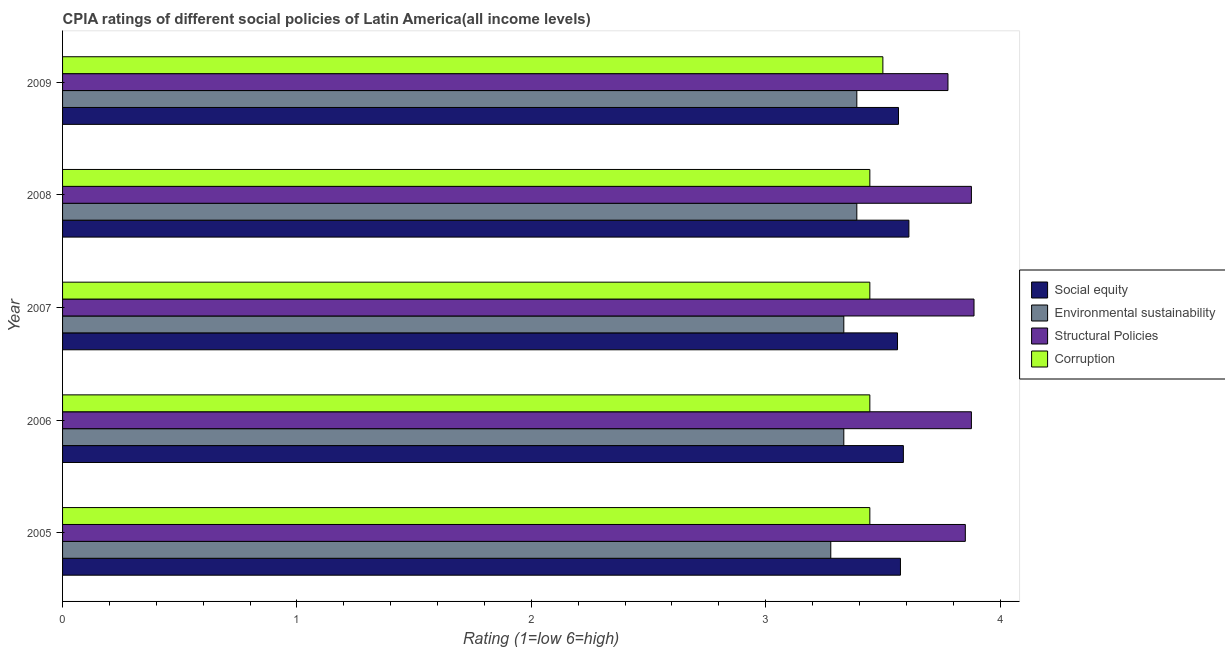Are the number of bars per tick equal to the number of legend labels?
Give a very brief answer. Yes. Are the number of bars on each tick of the Y-axis equal?
Your answer should be very brief. Yes. How many bars are there on the 4th tick from the top?
Offer a very short reply. 4. What is the label of the 2nd group of bars from the top?
Provide a short and direct response. 2008. What is the cpia rating of environmental sustainability in 2008?
Your answer should be very brief. 3.39. Across all years, what is the maximum cpia rating of structural policies?
Make the answer very short. 3.89. Across all years, what is the minimum cpia rating of environmental sustainability?
Give a very brief answer. 3.28. In which year was the cpia rating of structural policies maximum?
Give a very brief answer. 2007. In which year was the cpia rating of social equity minimum?
Offer a very short reply. 2007. What is the total cpia rating of structural policies in the graph?
Your answer should be compact. 19.27. What is the difference between the cpia rating of social equity in 2007 and that in 2008?
Provide a short and direct response. -0.05. What is the difference between the cpia rating of structural policies in 2009 and the cpia rating of corruption in 2005?
Provide a short and direct response. 0.33. What is the average cpia rating of structural policies per year?
Your answer should be very brief. 3.85. In the year 2009, what is the difference between the cpia rating of social equity and cpia rating of corruption?
Your response must be concise. 0.07. In how many years, is the cpia rating of environmental sustainability greater than 2.4 ?
Provide a short and direct response. 5. Is the cpia rating of social equity in 2007 less than that in 2008?
Give a very brief answer. Yes. Is the difference between the cpia rating of environmental sustainability in 2008 and 2009 greater than the difference between the cpia rating of social equity in 2008 and 2009?
Keep it short and to the point. No. What is the difference between the highest and the lowest cpia rating of structural policies?
Make the answer very short. 0.11. What does the 4th bar from the top in 2009 represents?
Offer a very short reply. Social equity. What does the 2nd bar from the bottom in 2005 represents?
Give a very brief answer. Environmental sustainability. Is it the case that in every year, the sum of the cpia rating of social equity and cpia rating of environmental sustainability is greater than the cpia rating of structural policies?
Offer a very short reply. Yes. How many bars are there?
Make the answer very short. 20. Are the values on the major ticks of X-axis written in scientific E-notation?
Provide a short and direct response. No. Does the graph contain grids?
Give a very brief answer. No. How many legend labels are there?
Your answer should be compact. 4. What is the title of the graph?
Offer a terse response. CPIA ratings of different social policies of Latin America(all income levels). What is the Rating (1=low 6=high) in Social equity in 2005?
Keep it short and to the point. 3.58. What is the Rating (1=low 6=high) in Environmental sustainability in 2005?
Offer a very short reply. 3.28. What is the Rating (1=low 6=high) of Structural Policies in 2005?
Keep it short and to the point. 3.85. What is the Rating (1=low 6=high) of Corruption in 2005?
Offer a very short reply. 3.44. What is the Rating (1=low 6=high) in Social equity in 2006?
Offer a very short reply. 3.59. What is the Rating (1=low 6=high) of Environmental sustainability in 2006?
Offer a terse response. 3.33. What is the Rating (1=low 6=high) of Structural Policies in 2006?
Provide a succinct answer. 3.88. What is the Rating (1=low 6=high) in Corruption in 2006?
Ensure brevity in your answer.  3.44. What is the Rating (1=low 6=high) of Social equity in 2007?
Ensure brevity in your answer.  3.56. What is the Rating (1=low 6=high) of Environmental sustainability in 2007?
Give a very brief answer. 3.33. What is the Rating (1=low 6=high) in Structural Policies in 2007?
Your answer should be compact. 3.89. What is the Rating (1=low 6=high) of Corruption in 2007?
Offer a terse response. 3.44. What is the Rating (1=low 6=high) of Social equity in 2008?
Keep it short and to the point. 3.61. What is the Rating (1=low 6=high) of Environmental sustainability in 2008?
Your answer should be compact. 3.39. What is the Rating (1=low 6=high) in Structural Policies in 2008?
Provide a short and direct response. 3.88. What is the Rating (1=low 6=high) of Corruption in 2008?
Your answer should be very brief. 3.44. What is the Rating (1=low 6=high) of Social equity in 2009?
Your response must be concise. 3.57. What is the Rating (1=low 6=high) of Environmental sustainability in 2009?
Give a very brief answer. 3.39. What is the Rating (1=low 6=high) in Structural Policies in 2009?
Provide a succinct answer. 3.78. Across all years, what is the maximum Rating (1=low 6=high) in Social equity?
Provide a short and direct response. 3.61. Across all years, what is the maximum Rating (1=low 6=high) of Environmental sustainability?
Your answer should be compact. 3.39. Across all years, what is the maximum Rating (1=low 6=high) of Structural Policies?
Make the answer very short. 3.89. Across all years, what is the minimum Rating (1=low 6=high) in Social equity?
Your answer should be compact. 3.56. Across all years, what is the minimum Rating (1=low 6=high) of Environmental sustainability?
Provide a short and direct response. 3.28. Across all years, what is the minimum Rating (1=low 6=high) in Structural Policies?
Make the answer very short. 3.78. Across all years, what is the minimum Rating (1=low 6=high) in Corruption?
Give a very brief answer. 3.44. What is the total Rating (1=low 6=high) of Social equity in the graph?
Your answer should be very brief. 17.9. What is the total Rating (1=low 6=high) in Environmental sustainability in the graph?
Give a very brief answer. 16.72. What is the total Rating (1=low 6=high) in Structural Policies in the graph?
Give a very brief answer. 19.27. What is the total Rating (1=low 6=high) of Corruption in the graph?
Ensure brevity in your answer.  17.28. What is the difference between the Rating (1=low 6=high) in Social equity in 2005 and that in 2006?
Provide a short and direct response. -0.01. What is the difference between the Rating (1=low 6=high) in Environmental sustainability in 2005 and that in 2006?
Offer a very short reply. -0.06. What is the difference between the Rating (1=low 6=high) of Structural Policies in 2005 and that in 2006?
Your answer should be compact. -0.03. What is the difference between the Rating (1=low 6=high) in Corruption in 2005 and that in 2006?
Provide a succinct answer. 0. What is the difference between the Rating (1=low 6=high) of Social equity in 2005 and that in 2007?
Your response must be concise. 0.01. What is the difference between the Rating (1=low 6=high) in Environmental sustainability in 2005 and that in 2007?
Make the answer very short. -0.06. What is the difference between the Rating (1=low 6=high) in Structural Policies in 2005 and that in 2007?
Your answer should be very brief. -0.04. What is the difference between the Rating (1=low 6=high) in Social equity in 2005 and that in 2008?
Ensure brevity in your answer.  -0.04. What is the difference between the Rating (1=low 6=high) in Environmental sustainability in 2005 and that in 2008?
Your answer should be compact. -0.11. What is the difference between the Rating (1=low 6=high) of Structural Policies in 2005 and that in 2008?
Your answer should be very brief. -0.03. What is the difference between the Rating (1=low 6=high) of Corruption in 2005 and that in 2008?
Provide a succinct answer. 0. What is the difference between the Rating (1=low 6=high) of Social equity in 2005 and that in 2009?
Your response must be concise. 0.01. What is the difference between the Rating (1=low 6=high) in Environmental sustainability in 2005 and that in 2009?
Provide a short and direct response. -0.11. What is the difference between the Rating (1=low 6=high) in Structural Policies in 2005 and that in 2009?
Your answer should be very brief. 0.07. What is the difference between the Rating (1=low 6=high) in Corruption in 2005 and that in 2009?
Offer a very short reply. -0.06. What is the difference between the Rating (1=low 6=high) in Social equity in 2006 and that in 2007?
Your answer should be very brief. 0.03. What is the difference between the Rating (1=low 6=high) of Environmental sustainability in 2006 and that in 2007?
Your answer should be compact. 0. What is the difference between the Rating (1=low 6=high) in Structural Policies in 2006 and that in 2007?
Give a very brief answer. -0.01. What is the difference between the Rating (1=low 6=high) in Corruption in 2006 and that in 2007?
Offer a terse response. 0. What is the difference between the Rating (1=low 6=high) in Social equity in 2006 and that in 2008?
Your response must be concise. -0.02. What is the difference between the Rating (1=low 6=high) in Environmental sustainability in 2006 and that in 2008?
Your response must be concise. -0.06. What is the difference between the Rating (1=low 6=high) of Social equity in 2006 and that in 2009?
Offer a terse response. 0.02. What is the difference between the Rating (1=low 6=high) in Environmental sustainability in 2006 and that in 2009?
Keep it short and to the point. -0.06. What is the difference between the Rating (1=low 6=high) of Structural Policies in 2006 and that in 2009?
Your response must be concise. 0.1. What is the difference between the Rating (1=low 6=high) of Corruption in 2006 and that in 2009?
Make the answer very short. -0.06. What is the difference between the Rating (1=low 6=high) of Social equity in 2007 and that in 2008?
Ensure brevity in your answer.  -0.05. What is the difference between the Rating (1=low 6=high) in Environmental sustainability in 2007 and that in 2008?
Make the answer very short. -0.06. What is the difference between the Rating (1=low 6=high) in Structural Policies in 2007 and that in 2008?
Your answer should be very brief. 0.01. What is the difference between the Rating (1=low 6=high) in Corruption in 2007 and that in 2008?
Give a very brief answer. 0. What is the difference between the Rating (1=low 6=high) of Social equity in 2007 and that in 2009?
Provide a succinct answer. -0. What is the difference between the Rating (1=low 6=high) in Environmental sustainability in 2007 and that in 2009?
Your response must be concise. -0.06. What is the difference between the Rating (1=low 6=high) in Corruption in 2007 and that in 2009?
Offer a terse response. -0.06. What is the difference between the Rating (1=low 6=high) in Social equity in 2008 and that in 2009?
Ensure brevity in your answer.  0.04. What is the difference between the Rating (1=low 6=high) in Environmental sustainability in 2008 and that in 2009?
Offer a very short reply. 0. What is the difference between the Rating (1=low 6=high) of Corruption in 2008 and that in 2009?
Provide a short and direct response. -0.06. What is the difference between the Rating (1=low 6=high) of Social equity in 2005 and the Rating (1=low 6=high) of Environmental sustainability in 2006?
Offer a terse response. 0.24. What is the difference between the Rating (1=low 6=high) in Social equity in 2005 and the Rating (1=low 6=high) in Structural Policies in 2006?
Provide a short and direct response. -0.3. What is the difference between the Rating (1=low 6=high) of Social equity in 2005 and the Rating (1=low 6=high) of Corruption in 2006?
Make the answer very short. 0.13. What is the difference between the Rating (1=low 6=high) in Environmental sustainability in 2005 and the Rating (1=low 6=high) in Corruption in 2006?
Provide a succinct answer. -0.17. What is the difference between the Rating (1=low 6=high) of Structural Policies in 2005 and the Rating (1=low 6=high) of Corruption in 2006?
Offer a very short reply. 0.41. What is the difference between the Rating (1=low 6=high) of Social equity in 2005 and the Rating (1=low 6=high) of Environmental sustainability in 2007?
Make the answer very short. 0.24. What is the difference between the Rating (1=low 6=high) in Social equity in 2005 and the Rating (1=low 6=high) in Structural Policies in 2007?
Your answer should be very brief. -0.31. What is the difference between the Rating (1=low 6=high) of Social equity in 2005 and the Rating (1=low 6=high) of Corruption in 2007?
Your response must be concise. 0.13. What is the difference between the Rating (1=low 6=high) in Environmental sustainability in 2005 and the Rating (1=low 6=high) in Structural Policies in 2007?
Your response must be concise. -0.61. What is the difference between the Rating (1=low 6=high) in Environmental sustainability in 2005 and the Rating (1=low 6=high) in Corruption in 2007?
Give a very brief answer. -0.17. What is the difference between the Rating (1=low 6=high) of Structural Policies in 2005 and the Rating (1=low 6=high) of Corruption in 2007?
Your answer should be compact. 0.41. What is the difference between the Rating (1=low 6=high) in Social equity in 2005 and the Rating (1=low 6=high) in Environmental sustainability in 2008?
Give a very brief answer. 0.19. What is the difference between the Rating (1=low 6=high) of Social equity in 2005 and the Rating (1=low 6=high) of Structural Policies in 2008?
Make the answer very short. -0.3. What is the difference between the Rating (1=low 6=high) in Social equity in 2005 and the Rating (1=low 6=high) in Corruption in 2008?
Make the answer very short. 0.13. What is the difference between the Rating (1=low 6=high) in Environmental sustainability in 2005 and the Rating (1=low 6=high) in Corruption in 2008?
Offer a terse response. -0.17. What is the difference between the Rating (1=low 6=high) in Structural Policies in 2005 and the Rating (1=low 6=high) in Corruption in 2008?
Offer a terse response. 0.41. What is the difference between the Rating (1=low 6=high) in Social equity in 2005 and the Rating (1=low 6=high) in Environmental sustainability in 2009?
Ensure brevity in your answer.  0.19. What is the difference between the Rating (1=low 6=high) of Social equity in 2005 and the Rating (1=low 6=high) of Structural Policies in 2009?
Offer a very short reply. -0.2. What is the difference between the Rating (1=low 6=high) of Social equity in 2005 and the Rating (1=low 6=high) of Corruption in 2009?
Ensure brevity in your answer.  0.07. What is the difference between the Rating (1=low 6=high) of Environmental sustainability in 2005 and the Rating (1=low 6=high) of Structural Policies in 2009?
Make the answer very short. -0.5. What is the difference between the Rating (1=low 6=high) of Environmental sustainability in 2005 and the Rating (1=low 6=high) of Corruption in 2009?
Provide a succinct answer. -0.22. What is the difference between the Rating (1=low 6=high) of Structural Policies in 2005 and the Rating (1=low 6=high) of Corruption in 2009?
Offer a very short reply. 0.35. What is the difference between the Rating (1=low 6=high) of Social equity in 2006 and the Rating (1=low 6=high) of Environmental sustainability in 2007?
Provide a short and direct response. 0.25. What is the difference between the Rating (1=low 6=high) in Social equity in 2006 and the Rating (1=low 6=high) in Structural Policies in 2007?
Keep it short and to the point. -0.3. What is the difference between the Rating (1=low 6=high) in Social equity in 2006 and the Rating (1=low 6=high) in Corruption in 2007?
Your answer should be very brief. 0.14. What is the difference between the Rating (1=low 6=high) in Environmental sustainability in 2006 and the Rating (1=low 6=high) in Structural Policies in 2007?
Your answer should be very brief. -0.56. What is the difference between the Rating (1=low 6=high) in Environmental sustainability in 2006 and the Rating (1=low 6=high) in Corruption in 2007?
Provide a short and direct response. -0.11. What is the difference between the Rating (1=low 6=high) of Structural Policies in 2006 and the Rating (1=low 6=high) of Corruption in 2007?
Offer a terse response. 0.43. What is the difference between the Rating (1=low 6=high) of Social equity in 2006 and the Rating (1=low 6=high) of Environmental sustainability in 2008?
Your answer should be compact. 0.2. What is the difference between the Rating (1=low 6=high) in Social equity in 2006 and the Rating (1=low 6=high) in Structural Policies in 2008?
Provide a short and direct response. -0.29. What is the difference between the Rating (1=low 6=high) in Social equity in 2006 and the Rating (1=low 6=high) in Corruption in 2008?
Provide a short and direct response. 0.14. What is the difference between the Rating (1=low 6=high) in Environmental sustainability in 2006 and the Rating (1=low 6=high) in Structural Policies in 2008?
Offer a very short reply. -0.54. What is the difference between the Rating (1=low 6=high) of Environmental sustainability in 2006 and the Rating (1=low 6=high) of Corruption in 2008?
Offer a terse response. -0.11. What is the difference between the Rating (1=low 6=high) of Structural Policies in 2006 and the Rating (1=low 6=high) of Corruption in 2008?
Offer a terse response. 0.43. What is the difference between the Rating (1=low 6=high) in Social equity in 2006 and the Rating (1=low 6=high) in Environmental sustainability in 2009?
Provide a short and direct response. 0.2. What is the difference between the Rating (1=low 6=high) of Social equity in 2006 and the Rating (1=low 6=high) of Structural Policies in 2009?
Make the answer very short. -0.19. What is the difference between the Rating (1=low 6=high) in Social equity in 2006 and the Rating (1=low 6=high) in Corruption in 2009?
Provide a short and direct response. 0.09. What is the difference between the Rating (1=low 6=high) of Environmental sustainability in 2006 and the Rating (1=low 6=high) of Structural Policies in 2009?
Make the answer very short. -0.44. What is the difference between the Rating (1=low 6=high) of Structural Policies in 2006 and the Rating (1=low 6=high) of Corruption in 2009?
Your answer should be very brief. 0.38. What is the difference between the Rating (1=low 6=high) in Social equity in 2007 and the Rating (1=low 6=high) in Environmental sustainability in 2008?
Your answer should be very brief. 0.17. What is the difference between the Rating (1=low 6=high) of Social equity in 2007 and the Rating (1=low 6=high) of Structural Policies in 2008?
Give a very brief answer. -0.32. What is the difference between the Rating (1=low 6=high) of Social equity in 2007 and the Rating (1=low 6=high) of Corruption in 2008?
Provide a short and direct response. 0.12. What is the difference between the Rating (1=low 6=high) in Environmental sustainability in 2007 and the Rating (1=low 6=high) in Structural Policies in 2008?
Your response must be concise. -0.54. What is the difference between the Rating (1=low 6=high) in Environmental sustainability in 2007 and the Rating (1=low 6=high) in Corruption in 2008?
Give a very brief answer. -0.11. What is the difference between the Rating (1=low 6=high) in Structural Policies in 2007 and the Rating (1=low 6=high) in Corruption in 2008?
Your answer should be very brief. 0.44. What is the difference between the Rating (1=low 6=high) of Social equity in 2007 and the Rating (1=low 6=high) of Environmental sustainability in 2009?
Your answer should be compact. 0.17. What is the difference between the Rating (1=low 6=high) in Social equity in 2007 and the Rating (1=low 6=high) in Structural Policies in 2009?
Make the answer very short. -0.22. What is the difference between the Rating (1=low 6=high) in Social equity in 2007 and the Rating (1=low 6=high) in Corruption in 2009?
Provide a succinct answer. 0.06. What is the difference between the Rating (1=low 6=high) of Environmental sustainability in 2007 and the Rating (1=low 6=high) of Structural Policies in 2009?
Provide a short and direct response. -0.44. What is the difference between the Rating (1=low 6=high) of Environmental sustainability in 2007 and the Rating (1=low 6=high) of Corruption in 2009?
Make the answer very short. -0.17. What is the difference between the Rating (1=low 6=high) of Structural Policies in 2007 and the Rating (1=low 6=high) of Corruption in 2009?
Make the answer very short. 0.39. What is the difference between the Rating (1=low 6=high) in Social equity in 2008 and the Rating (1=low 6=high) in Environmental sustainability in 2009?
Your answer should be very brief. 0.22. What is the difference between the Rating (1=low 6=high) in Environmental sustainability in 2008 and the Rating (1=low 6=high) in Structural Policies in 2009?
Your answer should be very brief. -0.39. What is the difference between the Rating (1=low 6=high) of Environmental sustainability in 2008 and the Rating (1=low 6=high) of Corruption in 2009?
Keep it short and to the point. -0.11. What is the difference between the Rating (1=low 6=high) in Structural Policies in 2008 and the Rating (1=low 6=high) in Corruption in 2009?
Provide a short and direct response. 0.38. What is the average Rating (1=low 6=high) in Social equity per year?
Your answer should be very brief. 3.58. What is the average Rating (1=low 6=high) in Environmental sustainability per year?
Your answer should be compact. 3.34. What is the average Rating (1=low 6=high) of Structural Policies per year?
Provide a succinct answer. 3.85. What is the average Rating (1=low 6=high) of Corruption per year?
Offer a very short reply. 3.46. In the year 2005, what is the difference between the Rating (1=low 6=high) of Social equity and Rating (1=low 6=high) of Environmental sustainability?
Your response must be concise. 0.3. In the year 2005, what is the difference between the Rating (1=low 6=high) in Social equity and Rating (1=low 6=high) in Structural Policies?
Your response must be concise. -0.28. In the year 2005, what is the difference between the Rating (1=low 6=high) in Social equity and Rating (1=low 6=high) in Corruption?
Your answer should be compact. 0.13. In the year 2005, what is the difference between the Rating (1=low 6=high) of Environmental sustainability and Rating (1=low 6=high) of Structural Policies?
Your response must be concise. -0.57. In the year 2005, what is the difference between the Rating (1=low 6=high) of Environmental sustainability and Rating (1=low 6=high) of Corruption?
Make the answer very short. -0.17. In the year 2005, what is the difference between the Rating (1=low 6=high) of Structural Policies and Rating (1=low 6=high) of Corruption?
Make the answer very short. 0.41. In the year 2006, what is the difference between the Rating (1=low 6=high) in Social equity and Rating (1=low 6=high) in Environmental sustainability?
Your response must be concise. 0.25. In the year 2006, what is the difference between the Rating (1=low 6=high) of Social equity and Rating (1=low 6=high) of Structural Policies?
Offer a very short reply. -0.29. In the year 2006, what is the difference between the Rating (1=low 6=high) in Social equity and Rating (1=low 6=high) in Corruption?
Provide a succinct answer. 0.14. In the year 2006, what is the difference between the Rating (1=low 6=high) in Environmental sustainability and Rating (1=low 6=high) in Structural Policies?
Your response must be concise. -0.54. In the year 2006, what is the difference between the Rating (1=low 6=high) in Environmental sustainability and Rating (1=low 6=high) in Corruption?
Your answer should be very brief. -0.11. In the year 2006, what is the difference between the Rating (1=low 6=high) of Structural Policies and Rating (1=low 6=high) of Corruption?
Your answer should be compact. 0.43. In the year 2007, what is the difference between the Rating (1=low 6=high) in Social equity and Rating (1=low 6=high) in Environmental sustainability?
Offer a terse response. 0.23. In the year 2007, what is the difference between the Rating (1=low 6=high) in Social equity and Rating (1=low 6=high) in Structural Policies?
Keep it short and to the point. -0.33. In the year 2007, what is the difference between the Rating (1=low 6=high) in Social equity and Rating (1=low 6=high) in Corruption?
Offer a very short reply. 0.12. In the year 2007, what is the difference between the Rating (1=low 6=high) in Environmental sustainability and Rating (1=low 6=high) in Structural Policies?
Make the answer very short. -0.56. In the year 2007, what is the difference between the Rating (1=low 6=high) in Environmental sustainability and Rating (1=low 6=high) in Corruption?
Ensure brevity in your answer.  -0.11. In the year 2007, what is the difference between the Rating (1=low 6=high) in Structural Policies and Rating (1=low 6=high) in Corruption?
Provide a short and direct response. 0.44. In the year 2008, what is the difference between the Rating (1=low 6=high) of Social equity and Rating (1=low 6=high) of Environmental sustainability?
Keep it short and to the point. 0.22. In the year 2008, what is the difference between the Rating (1=low 6=high) of Social equity and Rating (1=low 6=high) of Structural Policies?
Your answer should be very brief. -0.27. In the year 2008, what is the difference between the Rating (1=low 6=high) of Social equity and Rating (1=low 6=high) of Corruption?
Ensure brevity in your answer.  0.17. In the year 2008, what is the difference between the Rating (1=low 6=high) in Environmental sustainability and Rating (1=low 6=high) in Structural Policies?
Ensure brevity in your answer.  -0.49. In the year 2008, what is the difference between the Rating (1=low 6=high) in Environmental sustainability and Rating (1=low 6=high) in Corruption?
Your response must be concise. -0.06. In the year 2008, what is the difference between the Rating (1=low 6=high) of Structural Policies and Rating (1=low 6=high) of Corruption?
Give a very brief answer. 0.43. In the year 2009, what is the difference between the Rating (1=low 6=high) of Social equity and Rating (1=low 6=high) of Environmental sustainability?
Offer a very short reply. 0.18. In the year 2009, what is the difference between the Rating (1=low 6=high) in Social equity and Rating (1=low 6=high) in Structural Policies?
Your answer should be very brief. -0.21. In the year 2009, what is the difference between the Rating (1=low 6=high) of Social equity and Rating (1=low 6=high) of Corruption?
Provide a succinct answer. 0.07. In the year 2009, what is the difference between the Rating (1=low 6=high) of Environmental sustainability and Rating (1=low 6=high) of Structural Policies?
Offer a terse response. -0.39. In the year 2009, what is the difference between the Rating (1=low 6=high) of Environmental sustainability and Rating (1=low 6=high) of Corruption?
Your answer should be very brief. -0.11. In the year 2009, what is the difference between the Rating (1=low 6=high) of Structural Policies and Rating (1=low 6=high) of Corruption?
Offer a very short reply. 0.28. What is the ratio of the Rating (1=low 6=high) of Environmental sustainability in 2005 to that in 2006?
Ensure brevity in your answer.  0.98. What is the ratio of the Rating (1=low 6=high) of Corruption in 2005 to that in 2006?
Your answer should be very brief. 1. What is the ratio of the Rating (1=low 6=high) in Social equity in 2005 to that in 2007?
Offer a terse response. 1. What is the ratio of the Rating (1=low 6=high) of Environmental sustainability in 2005 to that in 2007?
Your response must be concise. 0.98. What is the ratio of the Rating (1=low 6=high) of Structural Policies in 2005 to that in 2007?
Ensure brevity in your answer.  0.99. What is the ratio of the Rating (1=low 6=high) of Environmental sustainability in 2005 to that in 2008?
Provide a succinct answer. 0.97. What is the ratio of the Rating (1=low 6=high) in Structural Policies in 2005 to that in 2008?
Your answer should be very brief. 0.99. What is the ratio of the Rating (1=low 6=high) in Social equity in 2005 to that in 2009?
Make the answer very short. 1. What is the ratio of the Rating (1=low 6=high) in Environmental sustainability in 2005 to that in 2009?
Make the answer very short. 0.97. What is the ratio of the Rating (1=low 6=high) of Structural Policies in 2005 to that in 2009?
Make the answer very short. 1.02. What is the ratio of the Rating (1=low 6=high) of Corruption in 2005 to that in 2009?
Provide a succinct answer. 0.98. What is the ratio of the Rating (1=low 6=high) of Social equity in 2006 to that in 2007?
Provide a succinct answer. 1.01. What is the ratio of the Rating (1=low 6=high) of Corruption in 2006 to that in 2007?
Provide a short and direct response. 1. What is the ratio of the Rating (1=low 6=high) of Environmental sustainability in 2006 to that in 2008?
Give a very brief answer. 0.98. What is the ratio of the Rating (1=low 6=high) in Structural Policies in 2006 to that in 2008?
Your answer should be very brief. 1. What is the ratio of the Rating (1=low 6=high) of Social equity in 2006 to that in 2009?
Make the answer very short. 1.01. What is the ratio of the Rating (1=low 6=high) in Environmental sustainability in 2006 to that in 2009?
Keep it short and to the point. 0.98. What is the ratio of the Rating (1=low 6=high) of Structural Policies in 2006 to that in 2009?
Offer a terse response. 1.03. What is the ratio of the Rating (1=low 6=high) of Corruption in 2006 to that in 2009?
Your response must be concise. 0.98. What is the ratio of the Rating (1=low 6=high) in Social equity in 2007 to that in 2008?
Provide a succinct answer. 0.99. What is the ratio of the Rating (1=low 6=high) in Environmental sustainability in 2007 to that in 2008?
Provide a succinct answer. 0.98. What is the ratio of the Rating (1=low 6=high) in Social equity in 2007 to that in 2009?
Your response must be concise. 1. What is the ratio of the Rating (1=low 6=high) in Environmental sustainability in 2007 to that in 2009?
Your answer should be very brief. 0.98. What is the ratio of the Rating (1=low 6=high) of Structural Policies in 2007 to that in 2009?
Give a very brief answer. 1.03. What is the ratio of the Rating (1=low 6=high) of Corruption in 2007 to that in 2009?
Offer a terse response. 0.98. What is the ratio of the Rating (1=low 6=high) in Social equity in 2008 to that in 2009?
Your answer should be compact. 1.01. What is the ratio of the Rating (1=low 6=high) in Structural Policies in 2008 to that in 2009?
Your answer should be very brief. 1.03. What is the ratio of the Rating (1=low 6=high) in Corruption in 2008 to that in 2009?
Keep it short and to the point. 0.98. What is the difference between the highest and the second highest Rating (1=low 6=high) in Social equity?
Ensure brevity in your answer.  0.02. What is the difference between the highest and the second highest Rating (1=low 6=high) of Environmental sustainability?
Your answer should be very brief. 0. What is the difference between the highest and the second highest Rating (1=low 6=high) in Structural Policies?
Provide a succinct answer. 0.01. What is the difference between the highest and the second highest Rating (1=low 6=high) in Corruption?
Your response must be concise. 0.06. What is the difference between the highest and the lowest Rating (1=low 6=high) in Social equity?
Your response must be concise. 0.05. What is the difference between the highest and the lowest Rating (1=low 6=high) of Corruption?
Keep it short and to the point. 0.06. 